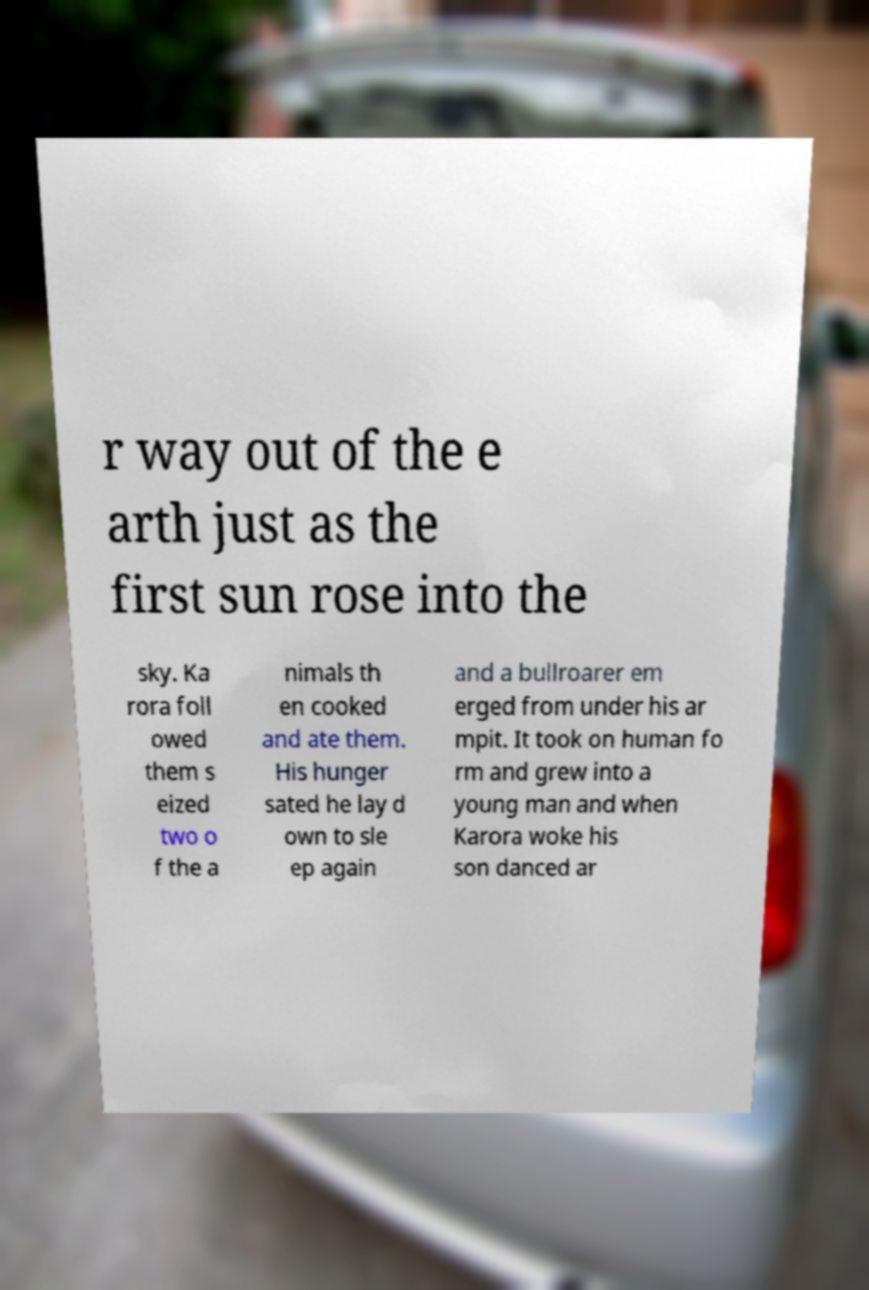Please read and relay the text visible in this image. What does it say? r way out of the e arth just as the first sun rose into the sky. Ka rora foll owed them s eized two o f the a nimals th en cooked and ate them. His hunger sated he lay d own to sle ep again and a bullroarer em erged from under his ar mpit. It took on human fo rm and grew into a young man and when Karora woke his son danced ar 